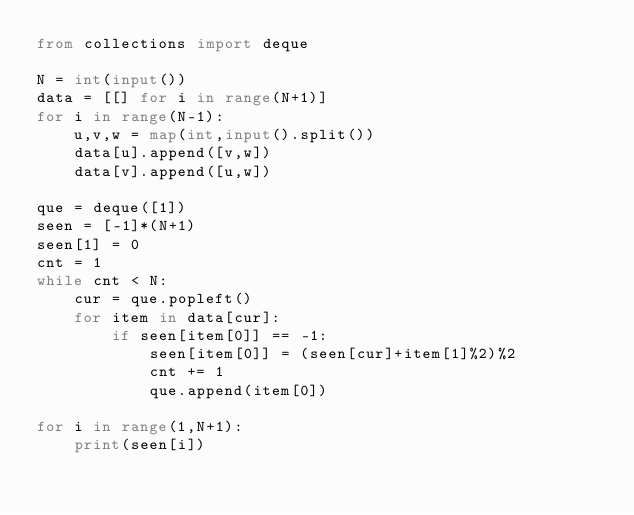Convert code to text. <code><loc_0><loc_0><loc_500><loc_500><_Python_>from collections import deque

N = int(input())
data = [[] for i in range(N+1)]
for i in range(N-1):
    u,v,w = map(int,input().split())
    data[u].append([v,w])
    data[v].append([u,w])

que = deque([1])
seen = [-1]*(N+1)
seen[1] = 0
cnt = 1
while cnt < N:
    cur = que.popleft()
    for item in data[cur]:
        if seen[item[0]] == -1:
            seen[item[0]] = (seen[cur]+item[1]%2)%2
            cnt += 1
            que.append(item[0])

for i in range(1,N+1):
    print(seen[i])</code> 